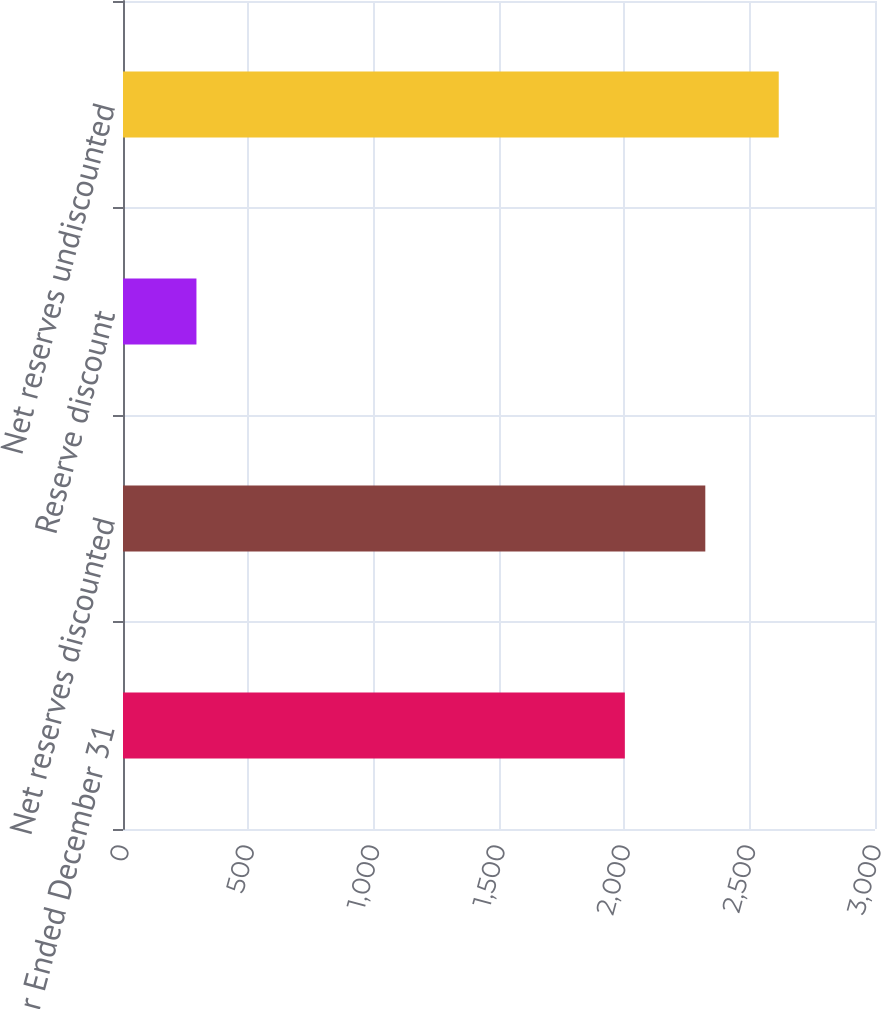<chart> <loc_0><loc_0><loc_500><loc_500><bar_chart><fcel>Year Ended December 31<fcel>Net reserves discounted<fcel>Reserve discount<fcel>Net reserves undiscounted<nl><fcel>2002<fcel>2323<fcel>293<fcel>2616<nl></chart> 